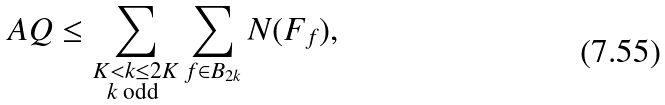<formula> <loc_0><loc_0><loc_500><loc_500>A Q \leq \sum _ { \substack { K < k \leq 2 K \\ k \text { odd } } } \sum _ { f \in B _ { 2 k } } N ( F _ { f } ) ,</formula> 